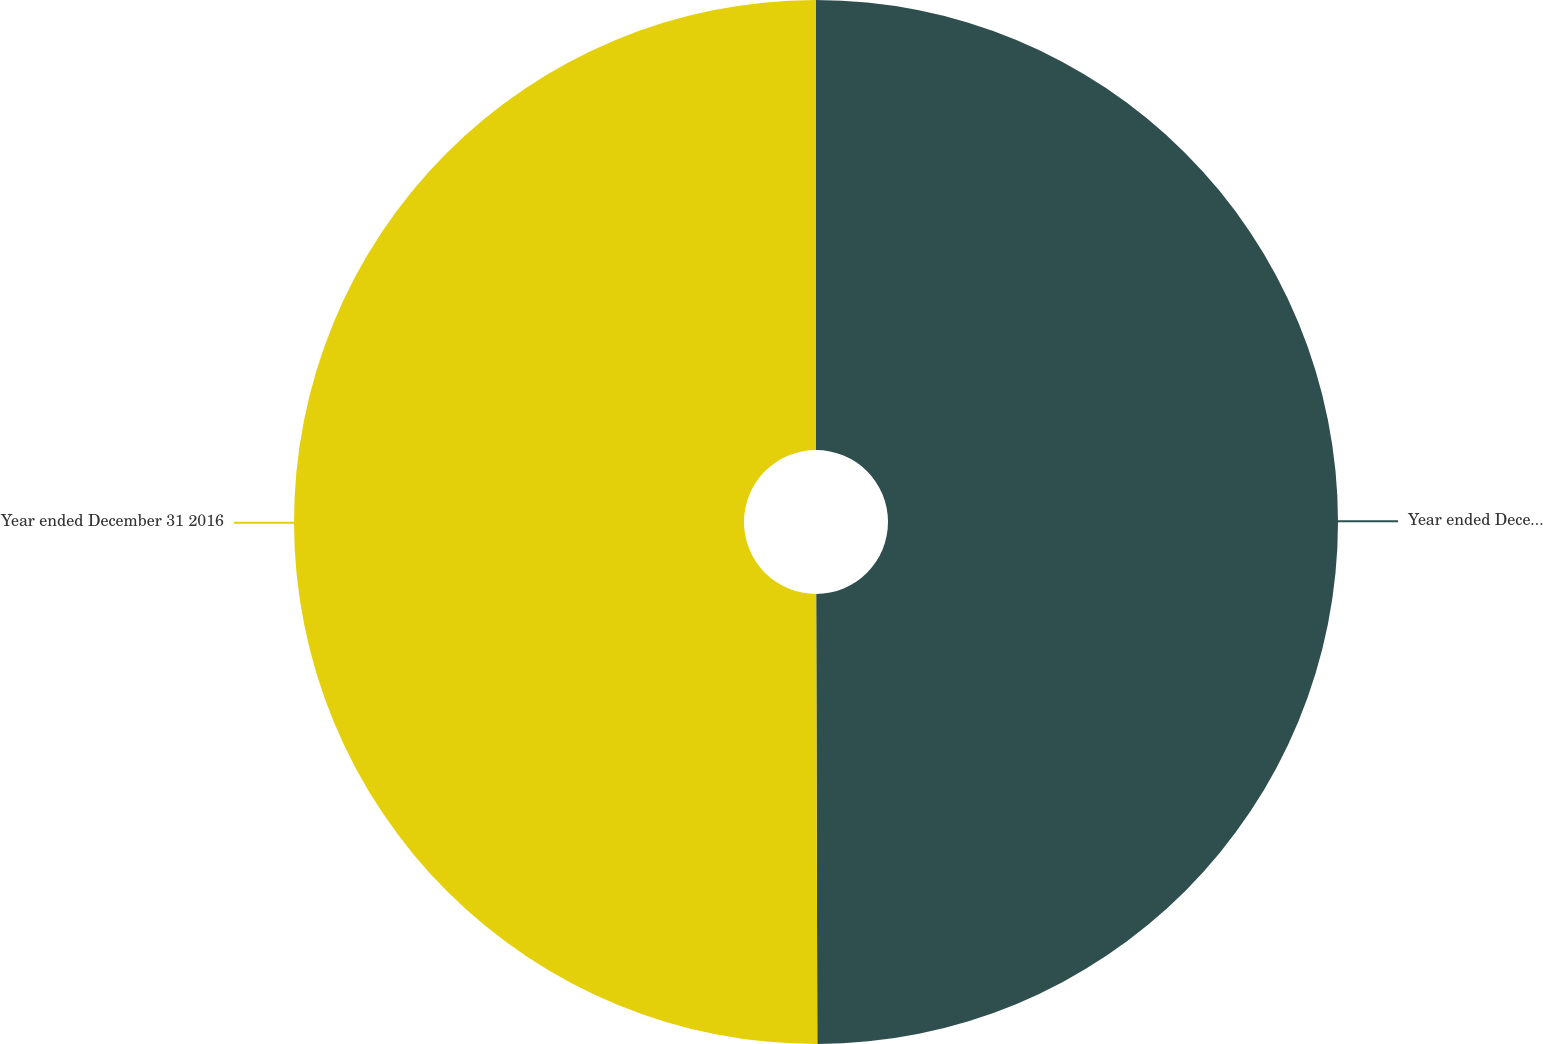Convert chart. <chart><loc_0><loc_0><loc_500><loc_500><pie_chart><fcel>Year ended December 31 2017<fcel>Year ended December 31 2016<nl><fcel>49.96%<fcel>50.04%<nl></chart> 